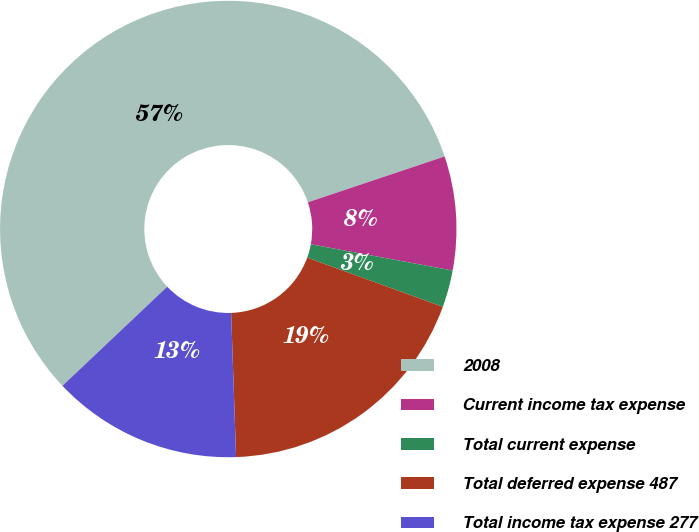Convert chart to OTSL. <chart><loc_0><loc_0><loc_500><loc_500><pie_chart><fcel>2008<fcel>Current income tax expense<fcel>Total current expense<fcel>Total deferred expense 487<fcel>Total income tax expense 277<nl><fcel>56.9%<fcel>8.06%<fcel>2.63%<fcel>18.91%<fcel>13.49%<nl></chart> 